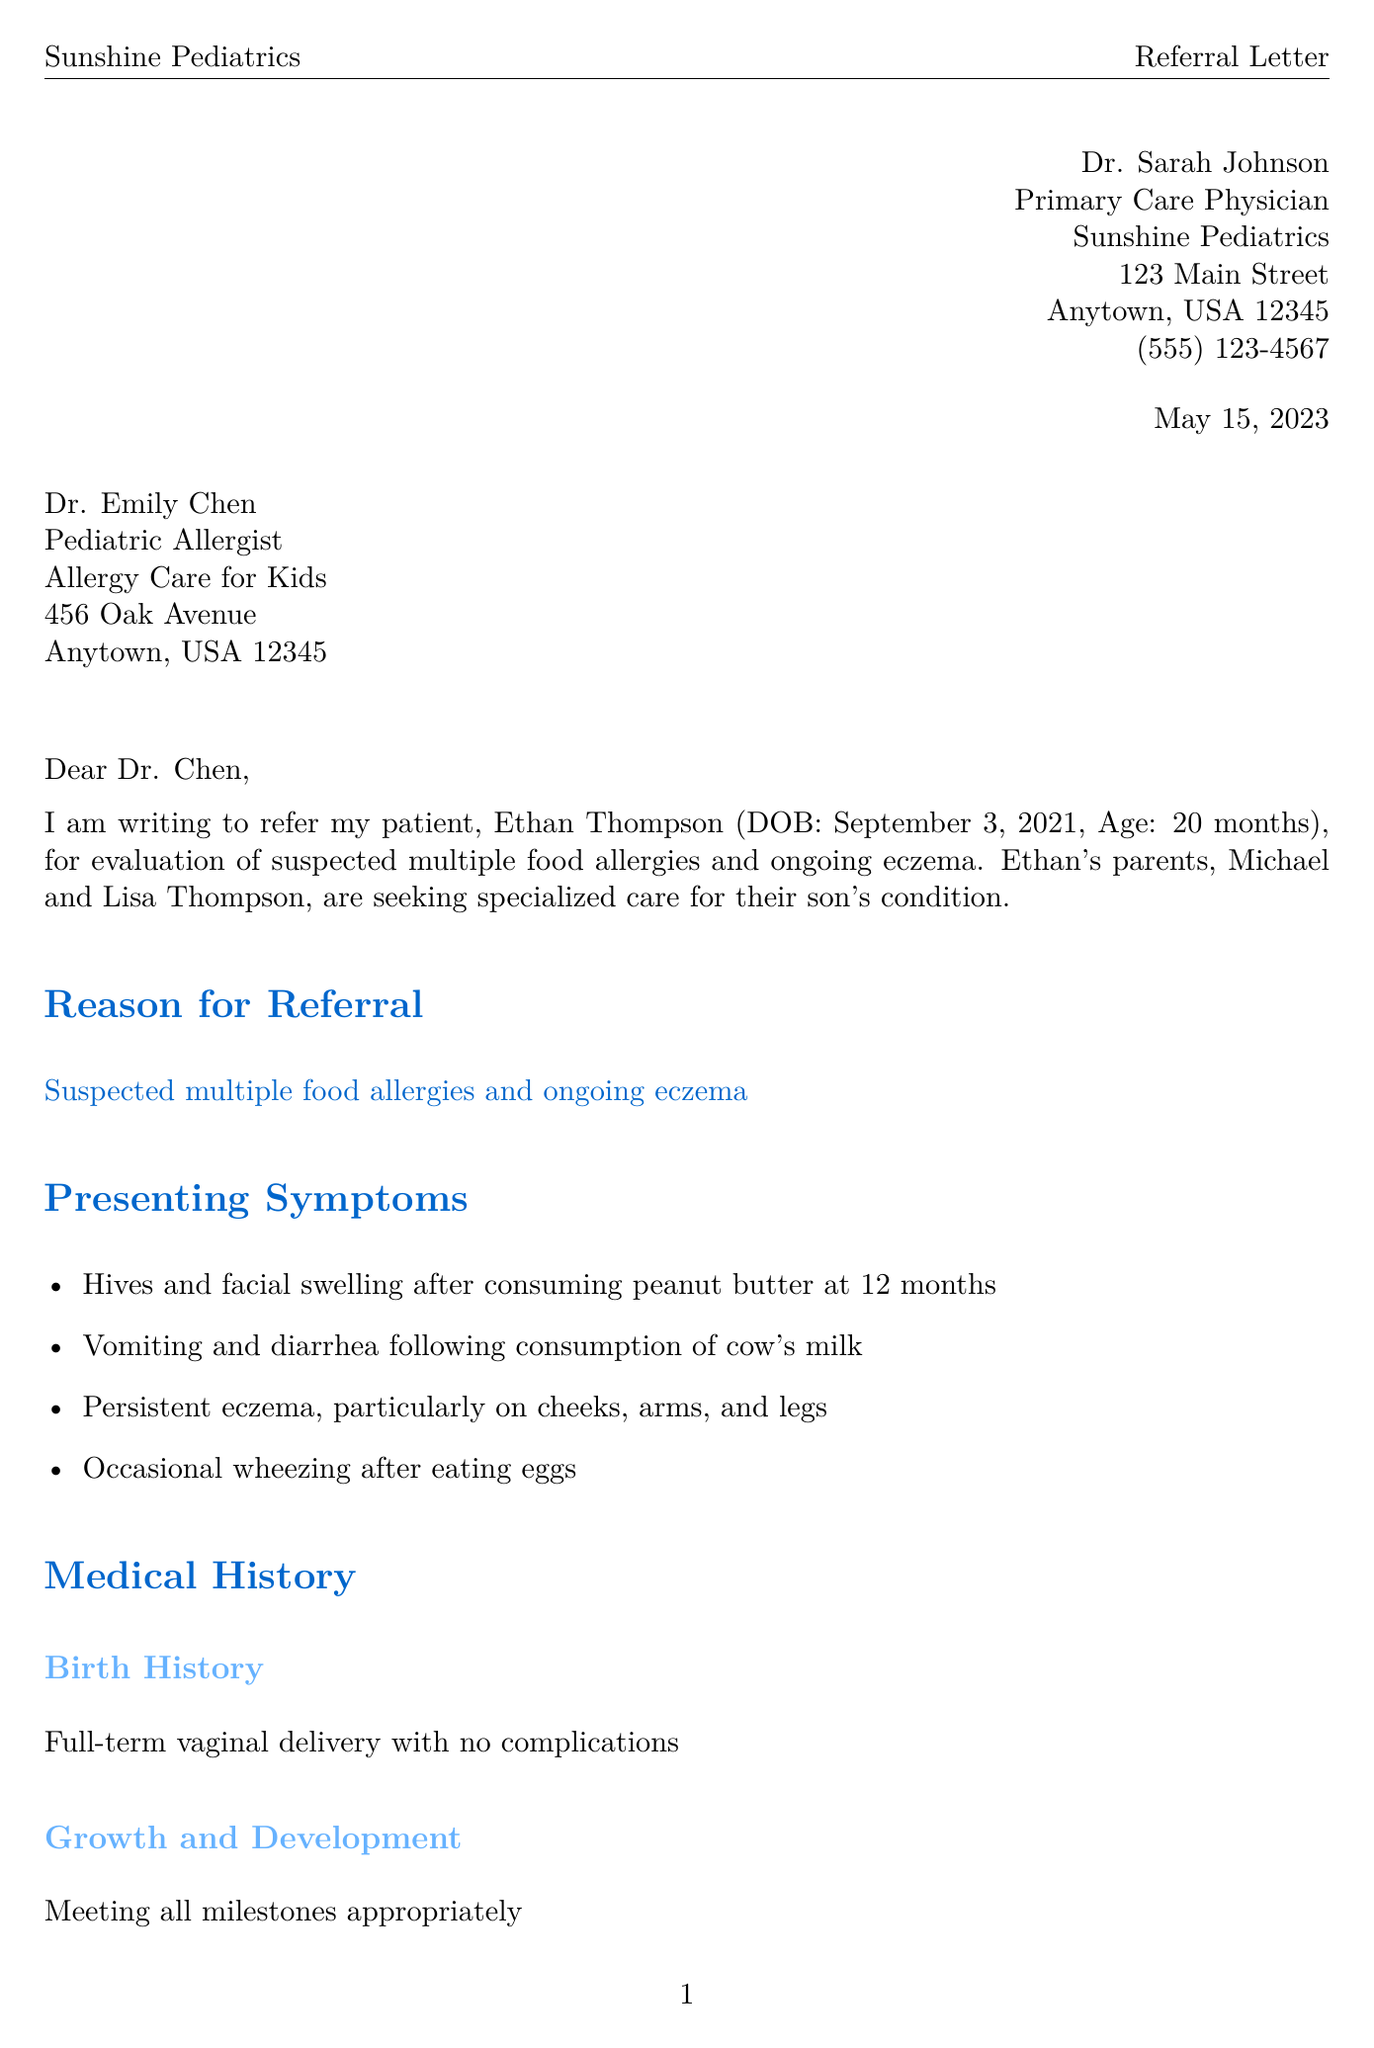What is the name of the referring physician? The referring physician is identified as the sender in the letter.
Answer: Dr. Sarah Johnson What is the date of the letter? The date mentioned at the top of the letter indicates when it was written.
Answer: May 15, 2023 What are Ethan's presenting symptoms? The symptoms are listed under "Presenting Symptoms" in the document.
Answer: Hives and facial swelling after consuming peanut butter, vomiting and diarrhea following consumption of cow's milk, persistent eczema, occasional wheezing after eating eggs What is Ethan's date of birth? The date of birth is provided in the patient's information section.
Answer: September 3, 2021 What medication is Ethan currently taking for allergy symptoms? The medication is listed under "Medications" in the medical history section.
Answer: Cetirizine 2.5mg daily What was Ethan's reaction to peanut butter? The incident and symptoms are detailed in the "Previous Allergy Symptoms and Treatments" section.
Answer: Hives, facial swelling What type of delivery did Ethan have? The type of delivery is specified in the "Birth History" subsection of the medical history.
Answer: Full-term vaginal delivery What is the total IgE level from the recent lab results? The total IgE level is presented under "Recent Laboratory Results" in the document.
Answer: Elevated at 150 IU/mL What kind of evaluation is requested for Ethan? The requested evaluations are outlined in the "Requested Evaluation" section.
Answer: Comprehensive allergy testing for common food allergens 